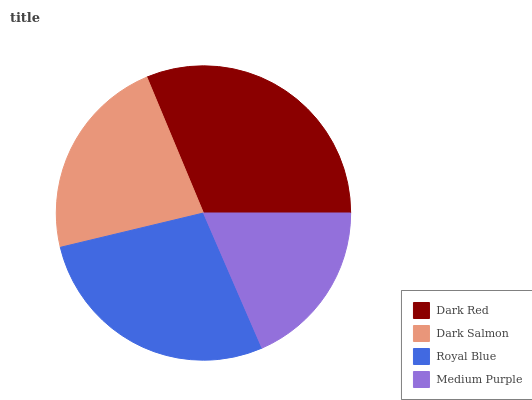Is Medium Purple the minimum?
Answer yes or no. Yes. Is Dark Red the maximum?
Answer yes or no. Yes. Is Dark Salmon the minimum?
Answer yes or no. No. Is Dark Salmon the maximum?
Answer yes or no. No. Is Dark Red greater than Dark Salmon?
Answer yes or no. Yes. Is Dark Salmon less than Dark Red?
Answer yes or no. Yes. Is Dark Salmon greater than Dark Red?
Answer yes or no. No. Is Dark Red less than Dark Salmon?
Answer yes or no. No. Is Royal Blue the high median?
Answer yes or no. Yes. Is Dark Salmon the low median?
Answer yes or no. Yes. Is Medium Purple the high median?
Answer yes or no. No. Is Medium Purple the low median?
Answer yes or no. No. 